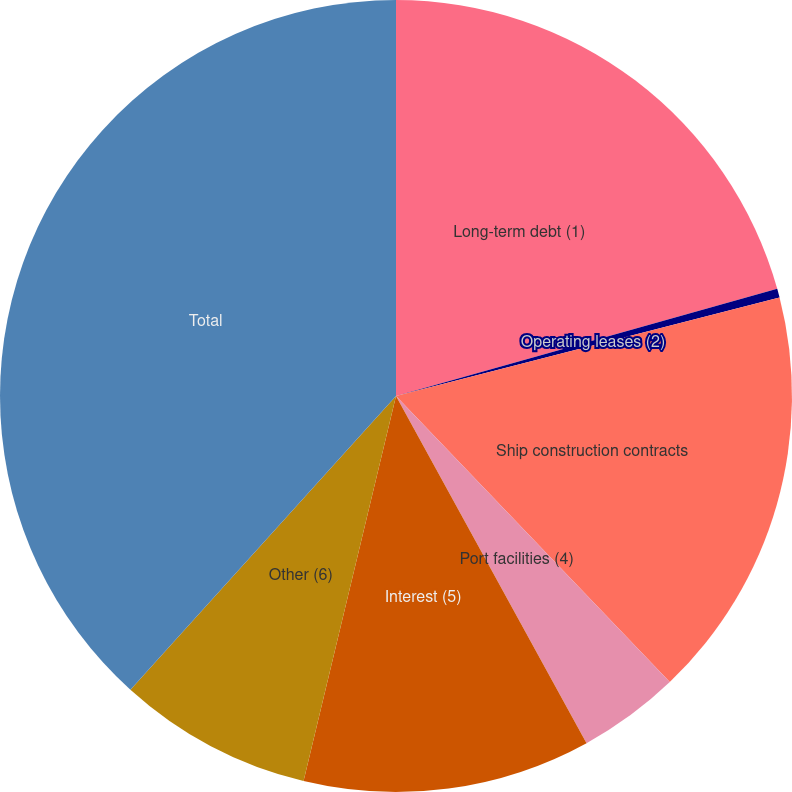Convert chart to OTSL. <chart><loc_0><loc_0><loc_500><loc_500><pie_chart><fcel>Long-term debt (1)<fcel>Operating leases (2)<fcel>Ship construction contracts<fcel>Port facilities (4)<fcel>Interest (5)<fcel>Other (6)<fcel>Total<nl><fcel>20.64%<fcel>0.36%<fcel>16.85%<fcel>4.16%<fcel>11.74%<fcel>7.95%<fcel>38.3%<nl></chart> 